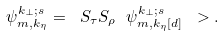Convert formula to latex. <formula><loc_0><loc_0><loc_500><loc_500>\psi ^ { k _ { \perp } ; s } _ { m , k _ { \eta } } = \ S _ { \tau } S _ { \rho } \ \psi ^ { k _ { \perp } ; s } _ { m , k _ { \eta } \mathrm [ d ] } \ > .</formula> 